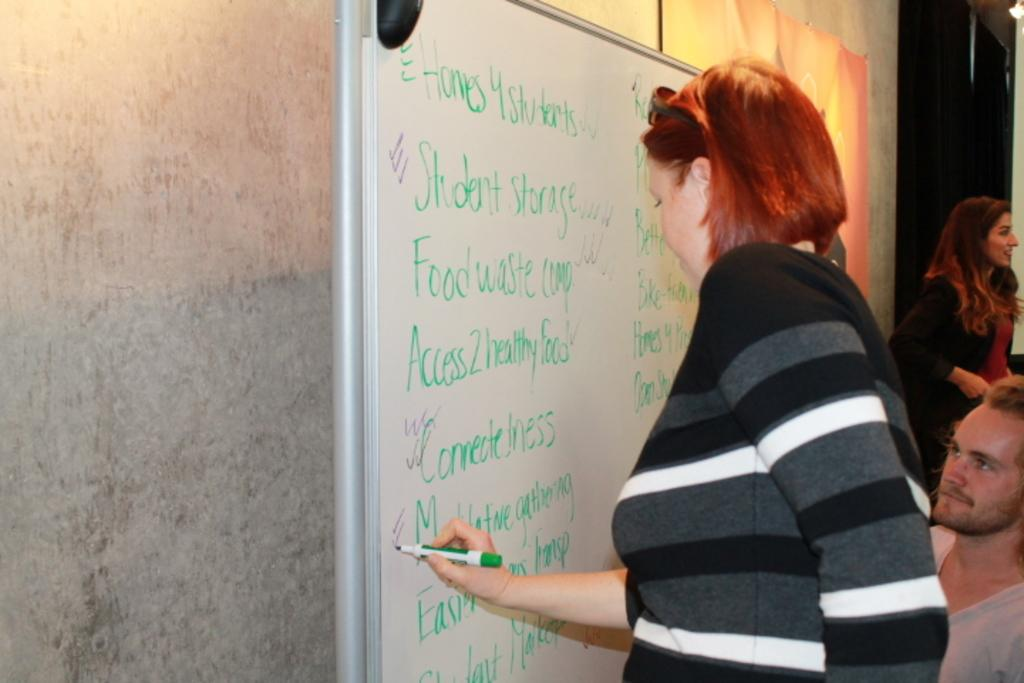<image>
Present a compact description of the photo's key features. A woman writes in green marker on a white board, the first line saying homes 4 students. 